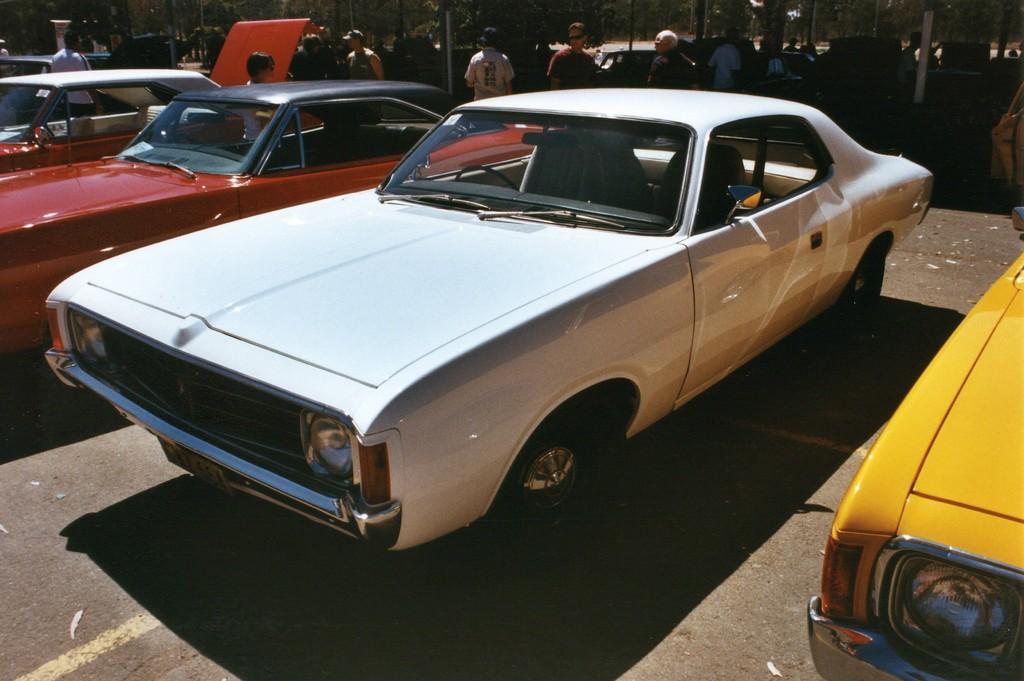Can you describe this image briefly? In this picture, we see the cars in white, red and yellow colors are parked on the road. Behind them, we see people standing on the road. In the background, there are many trees and poles. It is a sunny day. 